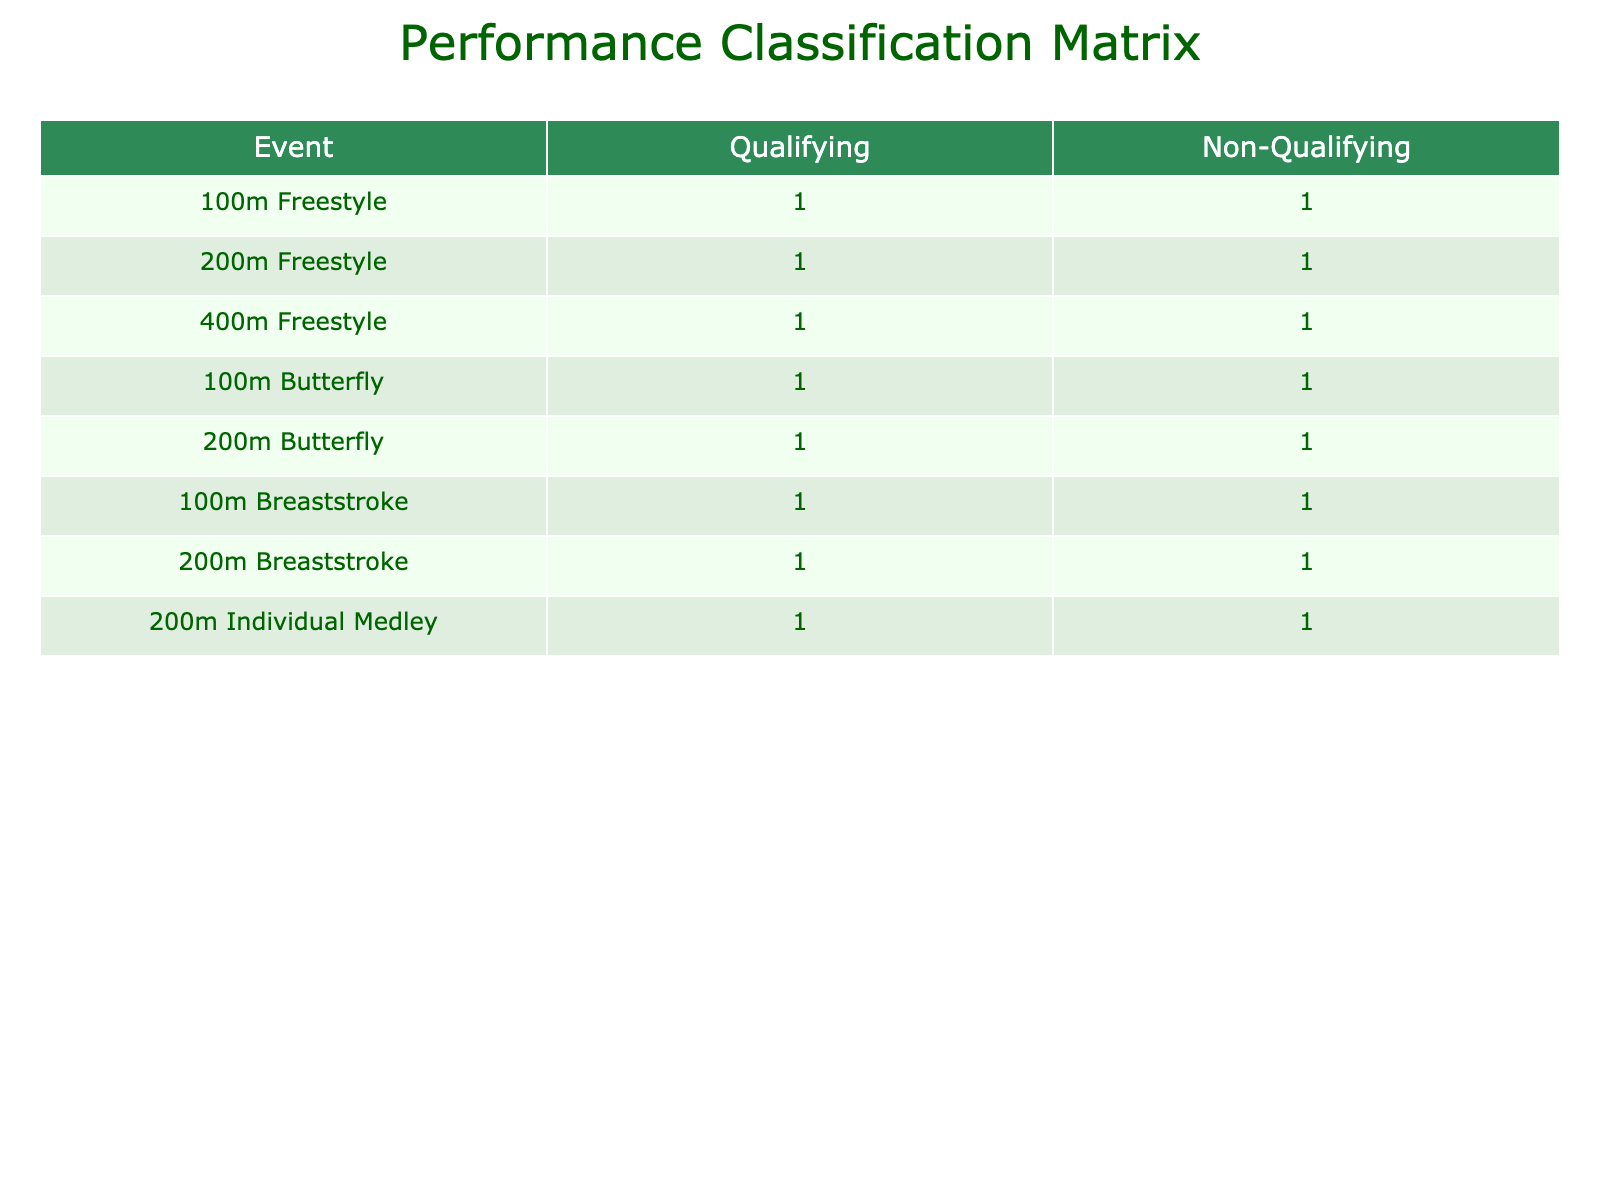What is the total number of qualifying events listed in the table? To find the total number of qualifying events, I will count all instances under the 'Qualifying' classification across all events. There are 6 qualifying events in total: 100m Freestyle, 200m Freestyle, 400m Freestyle, 100m Butterfly, 100m Breaststroke, and 200m Individual Medley.
Answer: 6 Which event has the highest number of non-qualifying swimmers? I will look at the column for non-qualifying classifications and see which event has the highest count. The events 200m Freestyle, 400m Freestyle, 100m Butterfly, 200m Butterfly, 100m Breaststroke, 200m Breaststroke, and 200m Individual Medley all have 1 non-qualifying swimmer each, while the 100m Freestyle has 1. Thus, every event listed has the same number of non-qualifying swimmers.
Answer: All events have 1 non-qualifying swimmer Is it true that the 200m Breaststroke event has a qualifying swimmer? To confirm this, I will check the 'Qualifying' classification for the 200m Breaststroke event. The data shows there is indeed a qualifying swimmer with a time of 2:15.80.
Answer: Yes What is the average qualifying time for the 100m events? I will calculate the average of qualifying times for the 100m events. The qualifying times are: 52.34 (100m Freestyle), 55.12 (100m Butterfly), and 1:02.75 (100m Breaststroke). Converting the last time to seconds gives us 62.75. The sum of these times in seconds is 52.34 + 55.12 + 62.75 = 170.21 seconds. There are 3 qualifying times, so the average is 170.21 / 3 = 56.74 seconds, which is approximately 56.74 when converted back.
Answer: 56.74 seconds How many swimmers achieved qualifying times in the 200m events? I will check the 200m events' qualifying counts. In the 200m Freestyle, there is 1 qualifying swimmer; in the 200m Butterfly, there is 1 qualifying swimmer; in the 200m Breaststroke, there is 1 qualifying swimmer; and in the 200m Individual Medley, there is also 1 qualifying swimmer. Therefore, I will sum these up: 1 + 1 + 1 + 1 = 4 qualifying swimmers across all 200m events.
Answer: 4 qualifying swimmers 